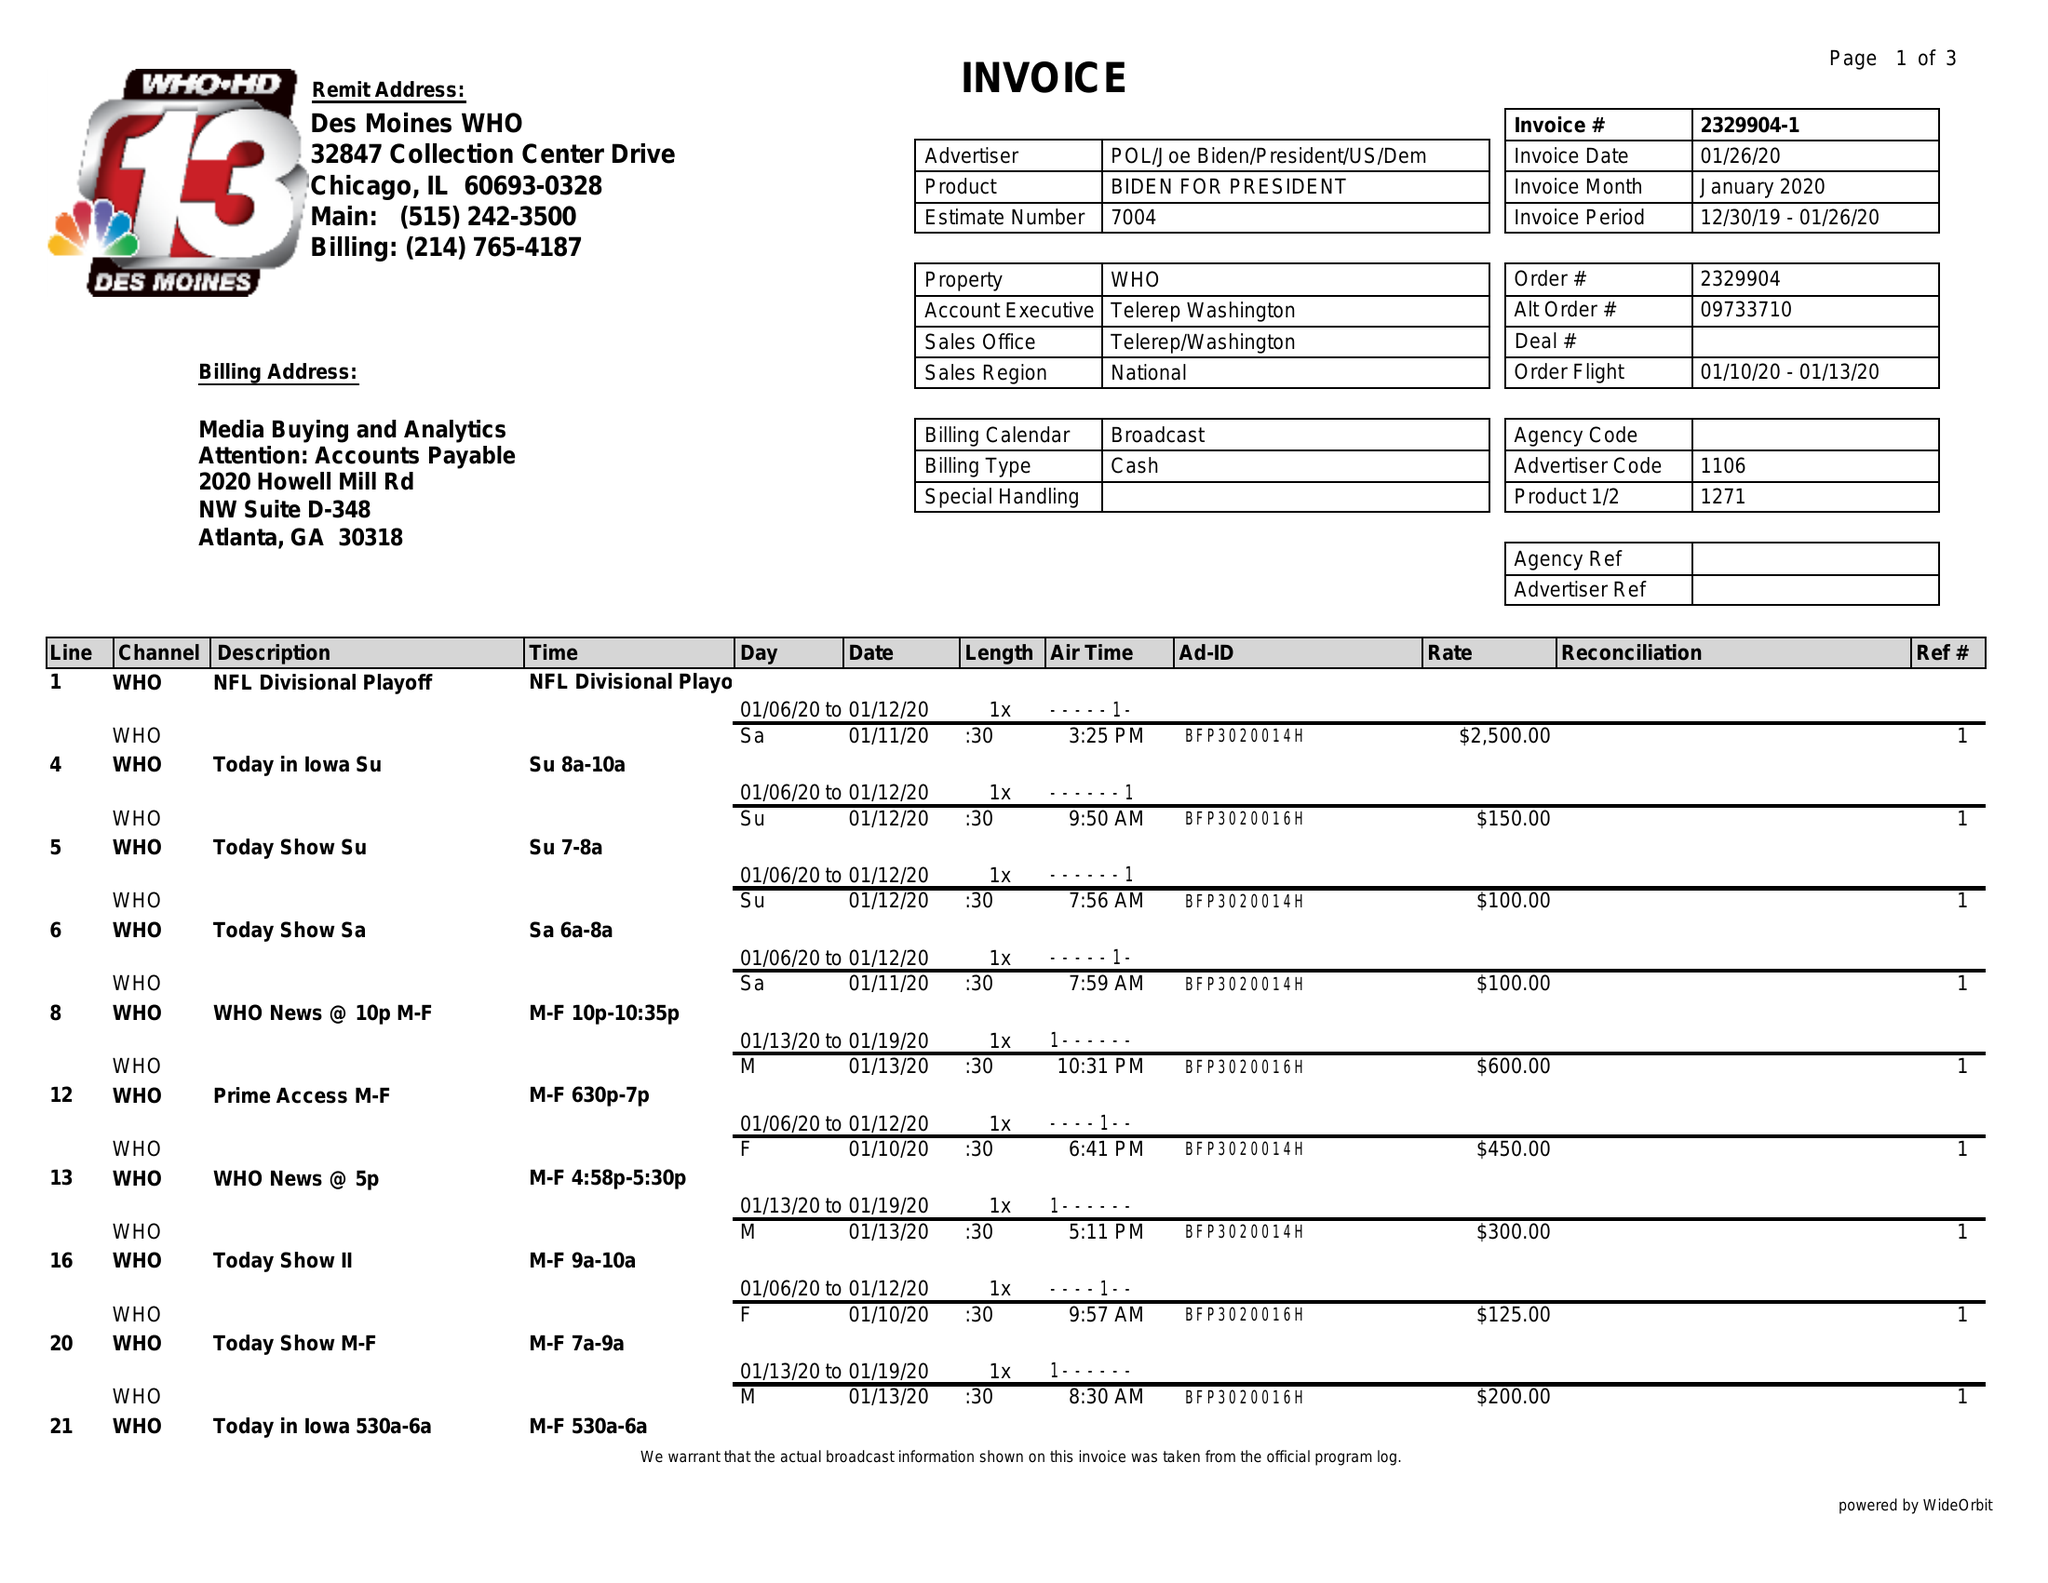What is the value for the gross_amount?
Answer the question using a single word or phrase. 8950.00 